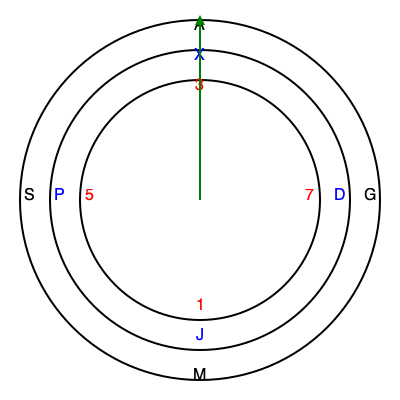During a covert operation, you intercept an encrypted message using a three-wheel cipher device. The outer wheel represents the plaintext alphabet, the middle wheel (in blue) is the first substitution, and the inner wheel (in red) is the second substitution. If the message "SGM" is received and the wheels are aligned as shown, what is the decrypted message? To decrypt the message, we need to reverse the substitution process using the cipher wheels:

1. Start with the received message: SGM

2. For each letter, we need to go from the outer wheel to the inner wheel, then back to the outer wheel:

   S:
   - On the outer wheel, find S
   - Move inward to the blue wheel: P
   - Move further inward to the red wheel: 5
   - Move outward to the blue wheel aligned with 5: X
   - Finally, move outward to the outer wheel aligned with X: A

   G:
   - On the outer wheel, find G
   - Move inward to the blue wheel: D
   - Move further inward to the red wheel: 7
   - Move outward to the blue wheel aligned with 7: J
   - Finally, move outward to the outer wheel aligned with J: M

   M:
   - On the outer wheel, find M
   - Move inward to the blue wheel: J
   - Move further inward to the red wheel: 1
   - Move outward to the blue wheel aligned with 1: X
   - Finally, move outward to the outer wheel aligned with X: A

3. Combining the decrypted letters, we get: AMA

Therefore, the decrypted message is "AMA".
Answer: AMA 